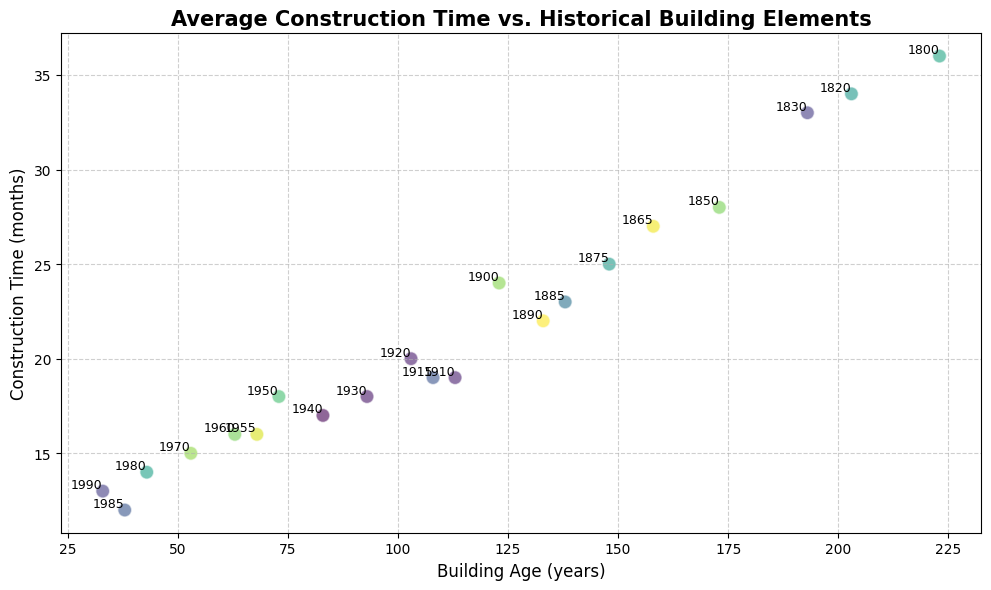Which building has the longest construction time? By examining the y-axis representing construction time in months, identify the data point with the highest position. This data point is associated with the year 1800, labeled next to it.
Answer: The building from 1800 Which two buildings have the closest construction times? By visually scanning the scatter plot, find the two points that are closest to each other along the y-axis. These points represent the construction times of the buildings built in 1970 and 1960 with values 15 and 16 months respectively.
Answer: Buildings from 1970 and 1960 How does the construction time generally change as the building age increases? Observe the scatter plot pattern. As buildings get older (move to the right along the x-axis), the y-axis values (construction time) generally increase, indicating a positive correlation.
Answer: Generally increases For buildings aged 100 years or more, what's the average construction time? Identify the points where the building age is 100 years or more (all points with x-axis values >= 100), then average their y-values: (36+28+24+33+25+22+34+27+23+19) / 10 = 27.1
Answer: 27.1 months Which decade saw a significant reduction in construction time? Look for a steep drop in the y-values between decades. Notice that between buildings from the 1950s and the 1960s, construction time drops from 18 months to 16 months.
Answer: 1960 What appears more variable, older or newer buildings' construction times? Compare the spread of points on the left versus the right side of the plot. There is more variability (wider spread) on the left side (older buildings) compared to the right side (newer buildings).
Answer: Older buildings Which building has almost the same construction time as the one from 1955? Identify the point near the 1955 construction time (16 months) — the one from 1960 also has a construction time of 16 months.
Answer: Building from 1960 How many buildings plotted are older than 150 years? Count all data points where the x-axis value (building age) is above 150 (years >= 1873), which gives us the points for 1800, 1850, 1830, 1820, 1865 (5 buildings).
Answer: 5 buildings What's the difference in construction time between the oldest and newest buildings? The oldest building (1800) has a construction time of 36 months, and the newest building (1990) has a construction time of 13 months. The difference is 36 - 13 = 23 months.
Answer: 23 months Which building has the shortest construction time and how does it compare to the one built in 1900? The shortest construction time is 12 months for the building from 1985. The construction time of the one built in 1900 is 24 months. Thus, 1985's construction time is 12 months shorter.
Answer: Building from 1985; 12 months shorter 